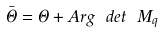<formula> <loc_0><loc_0><loc_500><loc_500>\bar { \Theta } = \Theta + A r g \ d e t \ M _ { q }</formula> 